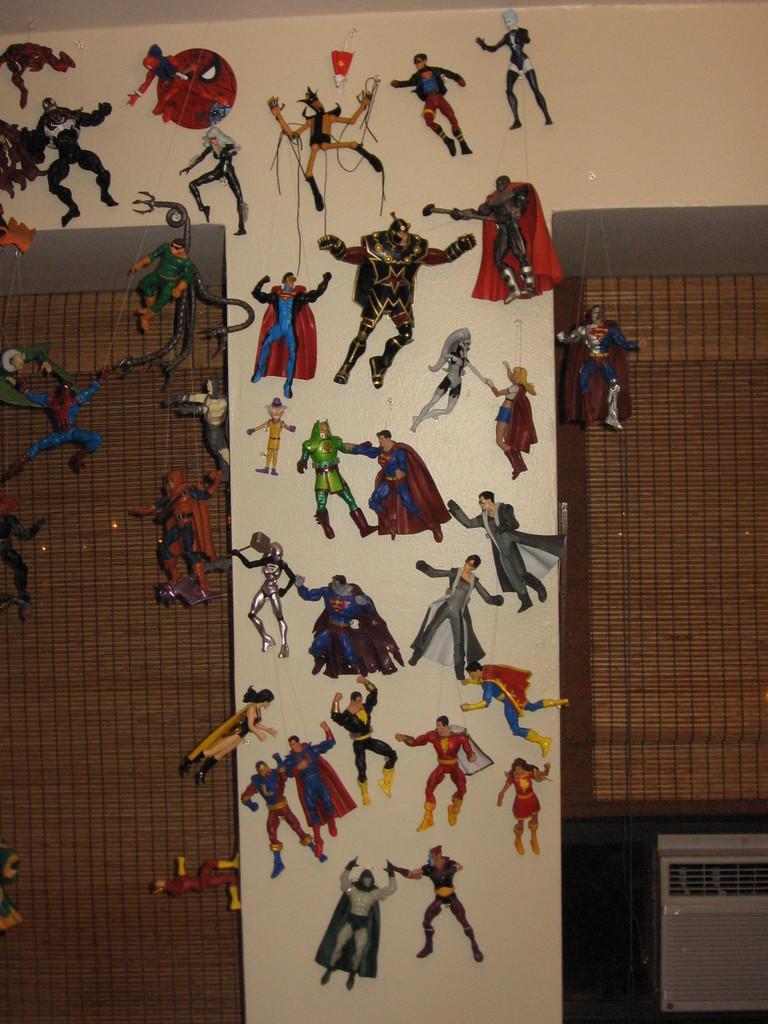Could you give a brief overview of what you see in this image? In this image there are stickers placed on the wall and there are curtains. 